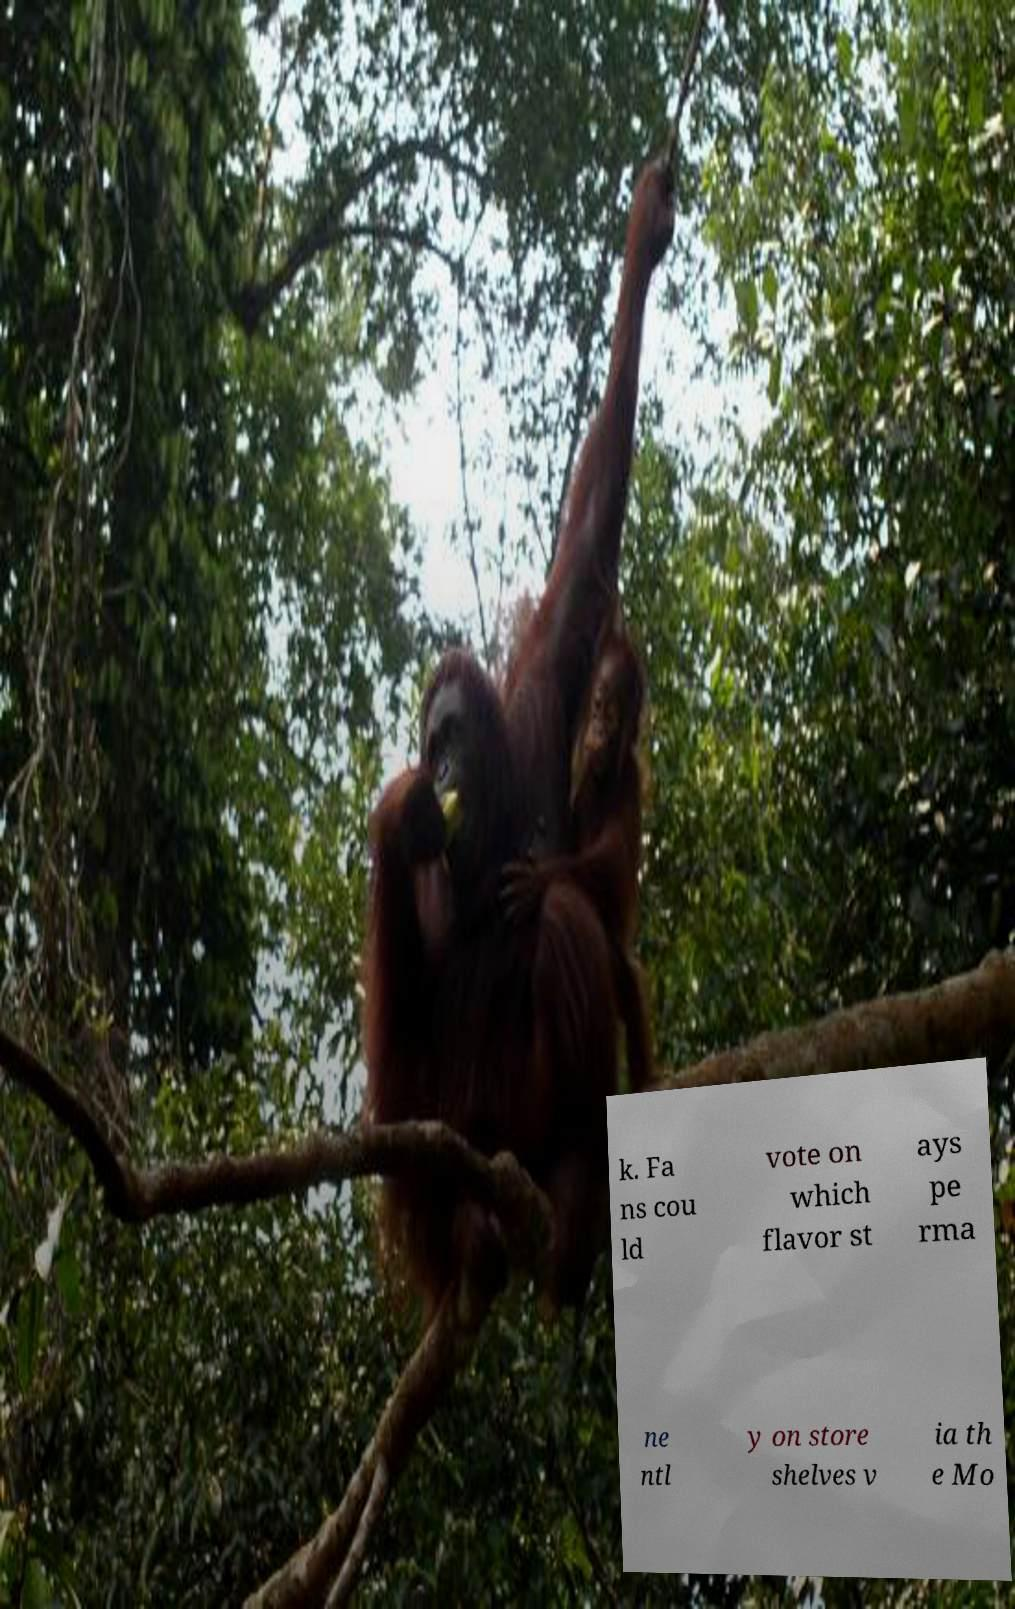Could you extract and type out the text from this image? k. Fa ns cou ld vote on which flavor st ays pe rma ne ntl y on store shelves v ia th e Mo 